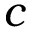<formula> <loc_0><loc_0><loc_500><loc_500>c</formula> 